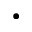Convert formula to latex. <formula><loc_0><loc_0><loc_500><loc_500>\bullet</formula> 